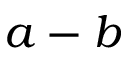<formula> <loc_0><loc_0><loc_500><loc_500>a - b</formula> 